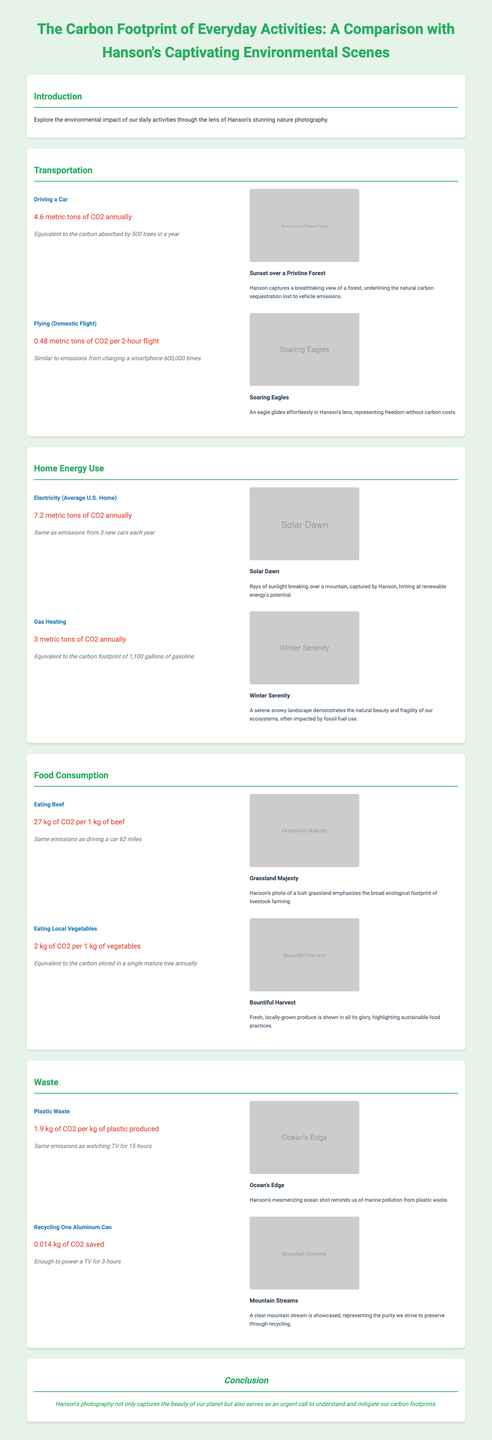what is the carbon footprint of driving a car? The document states that driving a car emits 4.6 metric tons of CO2 annually.
Answer: 4.6 metric tons of CO2 annually how many trees can absorb the car emissions? It is mentioned that the carbon absorbed by 500 trees in a year is equivalent to the emissions from driving a car.
Answer: 500 trees what are the emissions from a domestic flight? The infographic indicates that a domestic flight emits 0.48 metric tons of CO2 per 2-hour flight.
Answer: 0.48 metric tons of CO2 per 2-hour flight how much CO2 does eating beef generate? The document specifies that eating beef results in 27 kg of CO2 per 1 kg of beef.
Answer: 27 kg of CO2 per 1 kg of beef what is the CO2 footprint of electricity usage at an average U.S. home? The carbon footprint of electricity use for an average U.S. home is given as 7.2 metric tons of CO2 annually.
Answer: 7.2 metric tons of CO2 annually what do Hanson's photos represent regarding carbon sequestration? The photo titled "Sunset over a Pristine Forest" highlights the natural carbon sequestration lost to vehicle emissions.
Answer: Natural carbon sequestration lost to vehicle emissions how many kg of CO2 does local vegetable consumption produce? The document states that eating local vegetables generates 2 kg of CO2 per 1 kg of vegetables.
Answer: 2 kg of CO2 per 1 kg of vegetables what is the carbon footprint of plastic waste production? The infographic mentions that the carbon footprint for plastic waste production is 1.9 kg of CO2 per kg of plastic produced.
Answer: 1.9 kg of CO2 per kg of plastic produced 